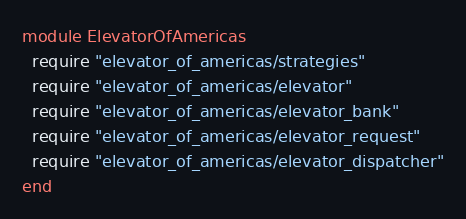<code> <loc_0><loc_0><loc_500><loc_500><_Ruby_>module ElevatorOfAmericas
  require "elevator_of_americas/strategies"
  require "elevator_of_americas/elevator"
  require "elevator_of_americas/elevator_bank"
  require "elevator_of_americas/elevator_request"
  require "elevator_of_americas/elevator_dispatcher"
end
</code> 